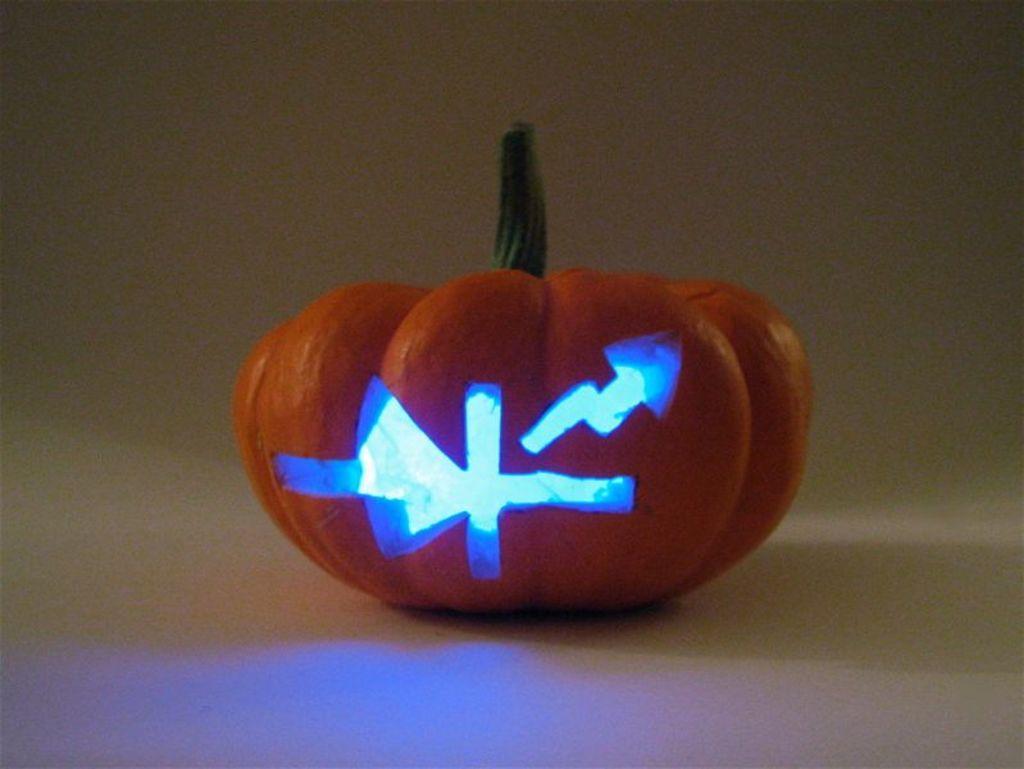Could you give a brief overview of what you see in this image? In this image I can see a fruit which is in orange color and I can see white background. 